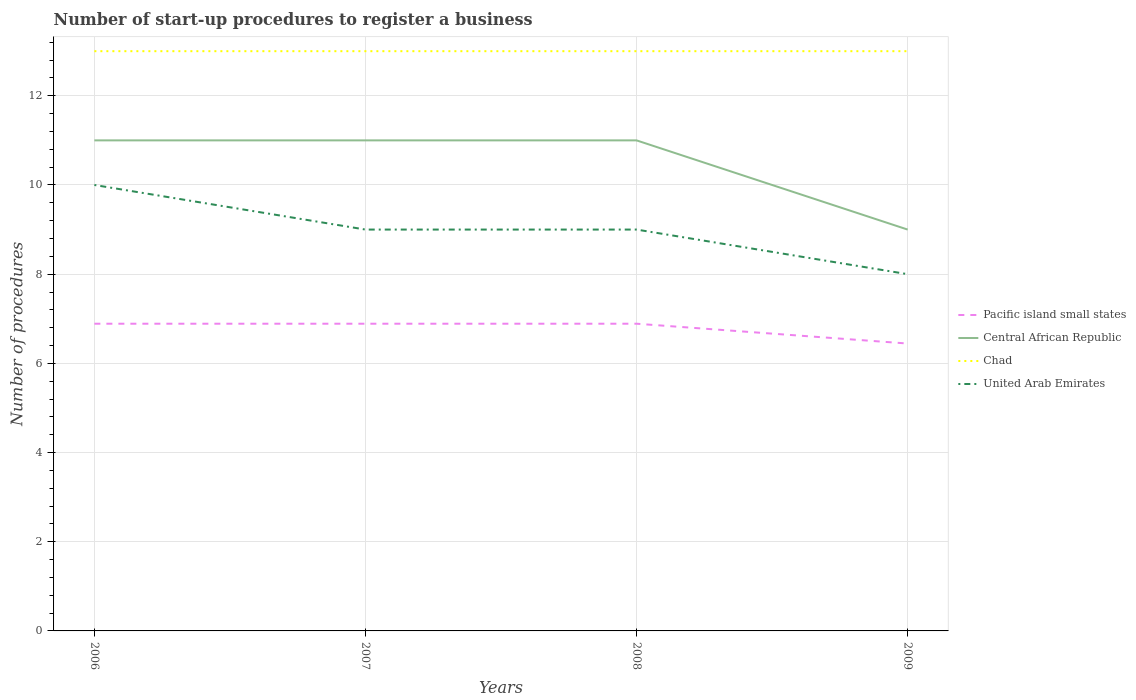How many different coloured lines are there?
Provide a succinct answer. 4. Across all years, what is the maximum number of procedures required to register a business in United Arab Emirates?
Your answer should be very brief. 8. In which year was the number of procedures required to register a business in United Arab Emirates maximum?
Provide a succinct answer. 2009. What is the total number of procedures required to register a business in United Arab Emirates in the graph?
Your answer should be very brief. 1. What is the difference between the highest and the second highest number of procedures required to register a business in United Arab Emirates?
Keep it short and to the point. 2. What is the difference between the highest and the lowest number of procedures required to register a business in Central African Republic?
Offer a terse response. 3. How many years are there in the graph?
Your answer should be very brief. 4. Does the graph contain grids?
Keep it short and to the point. Yes. Where does the legend appear in the graph?
Your response must be concise. Center right. How many legend labels are there?
Make the answer very short. 4. What is the title of the graph?
Keep it short and to the point. Number of start-up procedures to register a business. Does "Nepal" appear as one of the legend labels in the graph?
Offer a very short reply. No. What is the label or title of the Y-axis?
Offer a very short reply. Number of procedures. What is the Number of procedures in Pacific island small states in 2006?
Provide a short and direct response. 6.89. What is the Number of procedures of Pacific island small states in 2007?
Offer a terse response. 6.89. What is the Number of procedures of Central African Republic in 2007?
Your answer should be very brief. 11. What is the Number of procedures of Chad in 2007?
Your answer should be very brief. 13. What is the Number of procedures in Pacific island small states in 2008?
Your answer should be very brief. 6.89. What is the Number of procedures in United Arab Emirates in 2008?
Ensure brevity in your answer.  9. What is the Number of procedures of Pacific island small states in 2009?
Make the answer very short. 6.44. What is the Number of procedures of Central African Republic in 2009?
Ensure brevity in your answer.  9. What is the Number of procedures in United Arab Emirates in 2009?
Give a very brief answer. 8. Across all years, what is the maximum Number of procedures in Pacific island small states?
Provide a succinct answer. 6.89. Across all years, what is the maximum Number of procedures of Central African Republic?
Offer a terse response. 11. Across all years, what is the maximum Number of procedures of Chad?
Offer a terse response. 13. Across all years, what is the minimum Number of procedures of Pacific island small states?
Provide a short and direct response. 6.44. What is the total Number of procedures of Pacific island small states in the graph?
Your answer should be very brief. 27.11. What is the total Number of procedures of Central African Republic in the graph?
Offer a terse response. 42. What is the difference between the Number of procedures in Central African Republic in 2006 and that in 2007?
Your answer should be compact. 0. What is the difference between the Number of procedures of United Arab Emirates in 2006 and that in 2007?
Make the answer very short. 1. What is the difference between the Number of procedures in Pacific island small states in 2006 and that in 2009?
Provide a succinct answer. 0.44. What is the difference between the Number of procedures of Chad in 2006 and that in 2009?
Give a very brief answer. 0. What is the difference between the Number of procedures of Pacific island small states in 2007 and that in 2008?
Make the answer very short. 0. What is the difference between the Number of procedures of Chad in 2007 and that in 2008?
Your answer should be compact. 0. What is the difference between the Number of procedures in United Arab Emirates in 2007 and that in 2008?
Your response must be concise. 0. What is the difference between the Number of procedures of Pacific island small states in 2007 and that in 2009?
Your response must be concise. 0.44. What is the difference between the Number of procedures in Chad in 2007 and that in 2009?
Keep it short and to the point. 0. What is the difference between the Number of procedures of United Arab Emirates in 2007 and that in 2009?
Your answer should be compact. 1. What is the difference between the Number of procedures in Pacific island small states in 2008 and that in 2009?
Your answer should be very brief. 0.44. What is the difference between the Number of procedures of Central African Republic in 2008 and that in 2009?
Keep it short and to the point. 2. What is the difference between the Number of procedures of Chad in 2008 and that in 2009?
Provide a succinct answer. 0. What is the difference between the Number of procedures of Pacific island small states in 2006 and the Number of procedures of Central African Republic in 2007?
Offer a very short reply. -4.11. What is the difference between the Number of procedures in Pacific island small states in 2006 and the Number of procedures in Chad in 2007?
Your answer should be very brief. -6.11. What is the difference between the Number of procedures of Pacific island small states in 2006 and the Number of procedures of United Arab Emirates in 2007?
Provide a succinct answer. -2.11. What is the difference between the Number of procedures of Central African Republic in 2006 and the Number of procedures of Chad in 2007?
Provide a succinct answer. -2. What is the difference between the Number of procedures in Central African Republic in 2006 and the Number of procedures in United Arab Emirates in 2007?
Offer a terse response. 2. What is the difference between the Number of procedures in Chad in 2006 and the Number of procedures in United Arab Emirates in 2007?
Your response must be concise. 4. What is the difference between the Number of procedures of Pacific island small states in 2006 and the Number of procedures of Central African Republic in 2008?
Offer a terse response. -4.11. What is the difference between the Number of procedures in Pacific island small states in 2006 and the Number of procedures in Chad in 2008?
Ensure brevity in your answer.  -6.11. What is the difference between the Number of procedures in Pacific island small states in 2006 and the Number of procedures in United Arab Emirates in 2008?
Ensure brevity in your answer.  -2.11. What is the difference between the Number of procedures in Central African Republic in 2006 and the Number of procedures in Chad in 2008?
Make the answer very short. -2. What is the difference between the Number of procedures in Chad in 2006 and the Number of procedures in United Arab Emirates in 2008?
Your answer should be compact. 4. What is the difference between the Number of procedures in Pacific island small states in 2006 and the Number of procedures in Central African Republic in 2009?
Your answer should be compact. -2.11. What is the difference between the Number of procedures of Pacific island small states in 2006 and the Number of procedures of Chad in 2009?
Your answer should be compact. -6.11. What is the difference between the Number of procedures in Pacific island small states in 2006 and the Number of procedures in United Arab Emirates in 2009?
Provide a short and direct response. -1.11. What is the difference between the Number of procedures in Central African Republic in 2006 and the Number of procedures in United Arab Emirates in 2009?
Offer a very short reply. 3. What is the difference between the Number of procedures in Pacific island small states in 2007 and the Number of procedures in Central African Republic in 2008?
Your answer should be very brief. -4.11. What is the difference between the Number of procedures of Pacific island small states in 2007 and the Number of procedures of Chad in 2008?
Make the answer very short. -6.11. What is the difference between the Number of procedures of Pacific island small states in 2007 and the Number of procedures of United Arab Emirates in 2008?
Give a very brief answer. -2.11. What is the difference between the Number of procedures of Central African Republic in 2007 and the Number of procedures of United Arab Emirates in 2008?
Your answer should be very brief. 2. What is the difference between the Number of procedures of Pacific island small states in 2007 and the Number of procedures of Central African Republic in 2009?
Ensure brevity in your answer.  -2.11. What is the difference between the Number of procedures of Pacific island small states in 2007 and the Number of procedures of Chad in 2009?
Your answer should be very brief. -6.11. What is the difference between the Number of procedures of Pacific island small states in 2007 and the Number of procedures of United Arab Emirates in 2009?
Offer a terse response. -1.11. What is the difference between the Number of procedures of Central African Republic in 2007 and the Number of procedures of Chad in 2009?
Offer a terse response. -2. What is the difference between the Number of procedures in Pacific island small states in 2008 and the Number of procedures in Central African Republic in 2009?
Make the answer very short. -2.11. What is the difference between the Number of procedures of Pacific island small states in 2008 and the Number of procedures of Chad in 2009?
Ensure brevity in your answer.  -6.11. What is the difference between the Number of procedures in Pacific island small states in 2008 and the Number of procedures in United Arab Emirates in 2009?
Provide a short and direct response. -1.11. What is the difference between the Number of procedures of Chad in 2008 and the Number of procedures of United Arab Emirates in 2009?
Your answer should be very brief. 5. What is the average Number of procedures of Pacific island small states per year?
Your answer should be compact. 6.78. What is the average Number of procedures of Central African Republic per year?
Your answer should be very brief. 10.5. In the year 2006, what is the difference between the Number of procedures of Pacific island small states and Number of procedures of Central African Republic?
Offer a terse response. -4.11. In the year 2006, what is the difference between the Number of procedures of Pacific island small states and Number of procedures of Chad?
Ensure brevity in your answer.  -6.11. In the year 2006, what is the difference between the Number of procedures in Pacific island small states and Number of procedures in United Arab Emirates?
Your answer should be very brief. -3.11. In the year 2006, what is the difference between the Number of procedures in Central African Republic and Number of procedures in Chad?
Provide a short and direct response. -2. In the year 2006, what is the difference between the Number of procedures in Central African Republic and Number of procedures in United Arab Emirates?
Give a very brief answer. 1. In the year 2006, what is the difference between the Number of procedures of Chad and Number of procedures of United Arab Emirates?
Ensure brevity in your answer.  3. In the year 2007, what is the difference between the Number of procedures in Pacific island small states and Number of procedures in Central African Republic?
Provide a short and direct response. -4.11. In the year 2007, what is the difference between the Number of procedures in Pacific island small states and Number of procedures in Chad?
Provide a succinct answer. -6.11. In the year 2007, what is the difference between the Number of procedures in Pacific island small states and Number of procedures in United Arab Emirates?
Ensure brevity in your answer.  -2.11. In the year 2007, what is the difference between the Number of procedures in Central African Republic and Number of procedures in United Arab Emirates?
Your response must be concise. 2. In the year 2008, what is the difference between the Number of procedures in Pacific island small states and Number of procedures in Central African Republic?
Offer a very short reply. -4.11. In the year 2008, what is the difference between the Number of procedures in Pacific island small states and Number of procedures in Chad?
Your answer should be compact. -6.11. In the year 2008, what is the difference between the Number of procedures in Pacific island small states and Number of procedures in United Arab Emirates?
Keep it short and to the point. -2.11. In the year 2008, what is the difference between the Number of procedures of Central African Republic and Number of procedures of Chad?
Your answer should be very brief. -2. In the year 2009, what is the difference between the Number of procedures of Pacific island small states and Number of procedures of Central African Republic?
Your answer should be very brief. -2.56. In the year 2009, what is the difference between the Number of procedures of Pacific island small states and Number of procedures of Chad?
Offer a very short reply. -6.56. In the year 2009, what is the difference between the Number of procedures of Pacific island small states and Number of procedures of United Arab Emirates?
Provide a short and direct response. -1.56. In the year 2009, what is the difference between the Number of procedures in Central African Republic and Number of procedures in Chad?
Your response must be concise. -4. What is the ratio of the Number of procedures in Chad in 2006 to that in 2007?
Keep it short and to the point. 1. What is the ratio of the Number of procedures of Central African Republic in 2006 to that in 2008?
Your answer should be compact. 1. What is the ratio of the Number of procedures of United Arab Emirates in 2006 to that in 2008?
Make the answer very short. 1.11. What is the ratio of the Number of procedures of Pacific island small states in 2006 to that in 2009?
Offer a very short reply. 1.07. What is the ratio of the Number of procedures of Central African Republic in 2006 to that in 2009?
Provide a short and direct response. 1.22. What is the ratio of the Number of procedures in United Arab Emirates in 2006 to that in 2009?
Your response must be concise. 1.25. What is the ratio of the Number of procedures in United Arab Emirates in 2007 to that in 2008?
Ensure brevity in your answer.  1. What is the ratio of the Number of procedures in Pacific island small states in 2007 to that in 2009?
Provide a short and direct response. 1.07. What is the ratio of the Number of procedures in Central African Republic in 2007 to that in 2009?
Ensure brevity in your answer.  1.22. What is the ratio of the Number of procedures in Chad in 2007 to that in 2009?
Offer a terse response. 1. What is the ratio of the Number of procedures of Pacific island small states in 2008 to that in 2009?
Give a very brief answer. 1.07. What is the ratio of the Number of procedures of Central African Republic in 2008 to that in 2009?
Offer a terse response. 1.22. What is the ratio of the Number of procedures of Chad in 2008 to that in 2009?
Ensure brevity in your answer.  1. What is the ratio of the Number of procedures in United Arab Emirates in 2008 to that in 2009?
Your answer should be compact. 1.12. What is the difference between the highest and the second highest Number of procedures of United Arab Emirates?
Give a very brief answer. 1. What is the difference between the highest and the lowest Number of procedures in Pacific island small states?
Keep it short and to the point. 0.44. What is the difference between the highest and the lowest Number of procedures of Central African Republic?
Offer a terse response. 2. What is the difference between the highest and the lowest Number of procedures of Chad?
Make the answer very short. 0. 